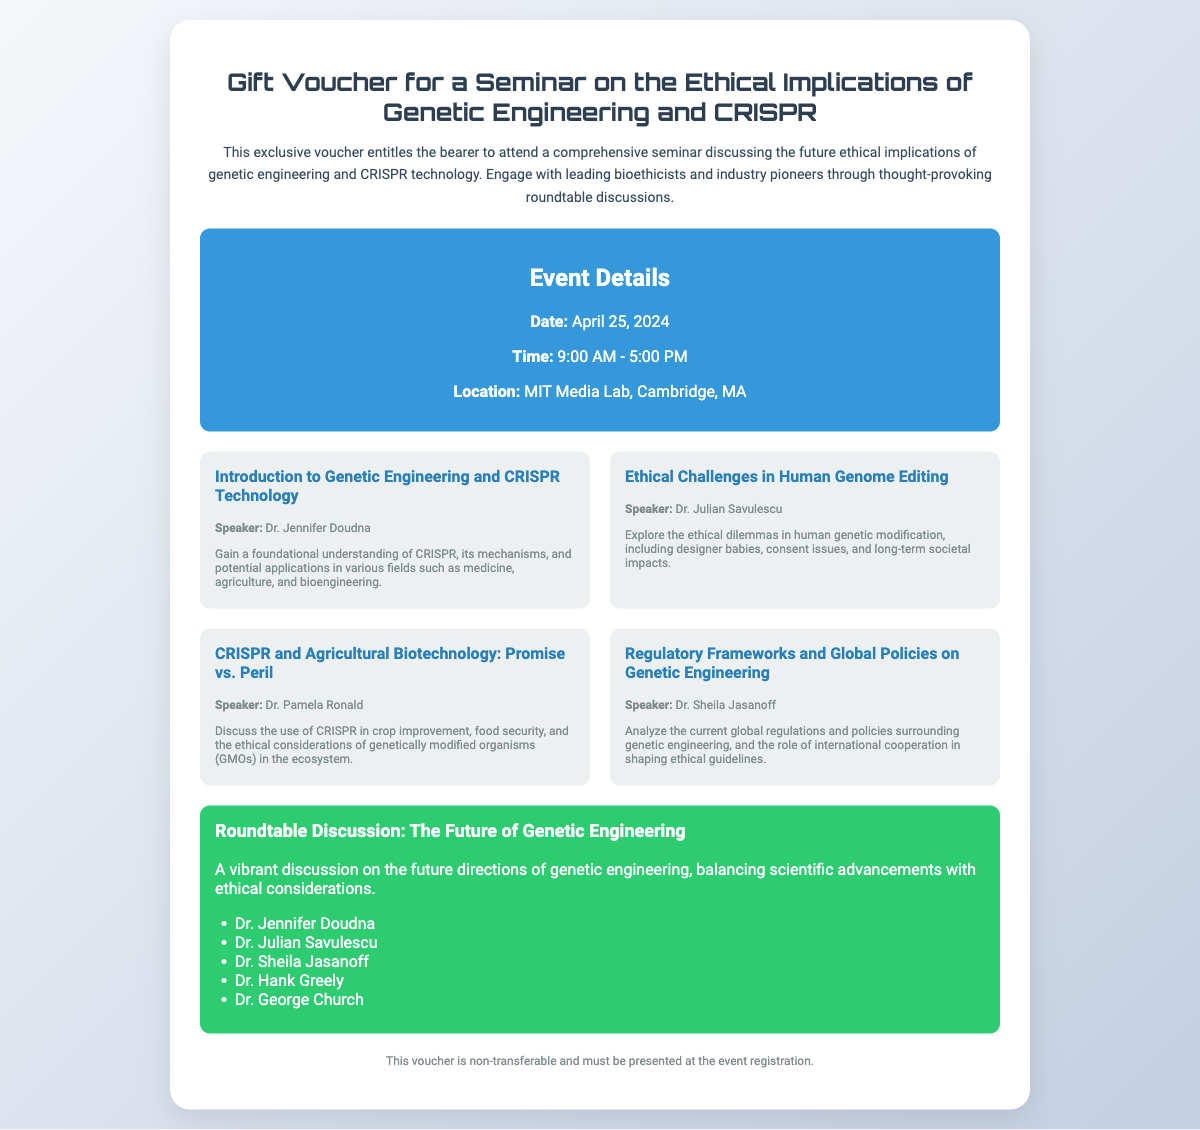What is the date of the seminar? The date of the seminar is explicitly stated in the event details section.
Answer: April 25, 2024 Who is the speaker for the session on ethical challenges in human genome editing? This information can be found in the highlights section that lists speakers for each session.
Answer: Dr. Julian Savulescu What is the main focus of the roundtable discussion? The roundtable section explicitly mentions the topic of the discussion.
Answer: The Future of Genetic Engineering Where is the seminar taking place? The location is specified in the event details.
Answer: MIT Media Lab, Cambridge, MA How many highlight sessions are detailed in the voucher? The number of highlight items is counted in the highlights section.
Answer: Four Which speaker discusses CRISPR and agricultural biotechnology? The highlights section identifies the speaker for this particular topic.
Answer: Dr. Pamela Ronald What type of event is this voucher for? The description at the top of the document provides the type of event.
Answer: Seminar Is the voucher transferable? This information is typically found in the footer of the document.
Answer: No 